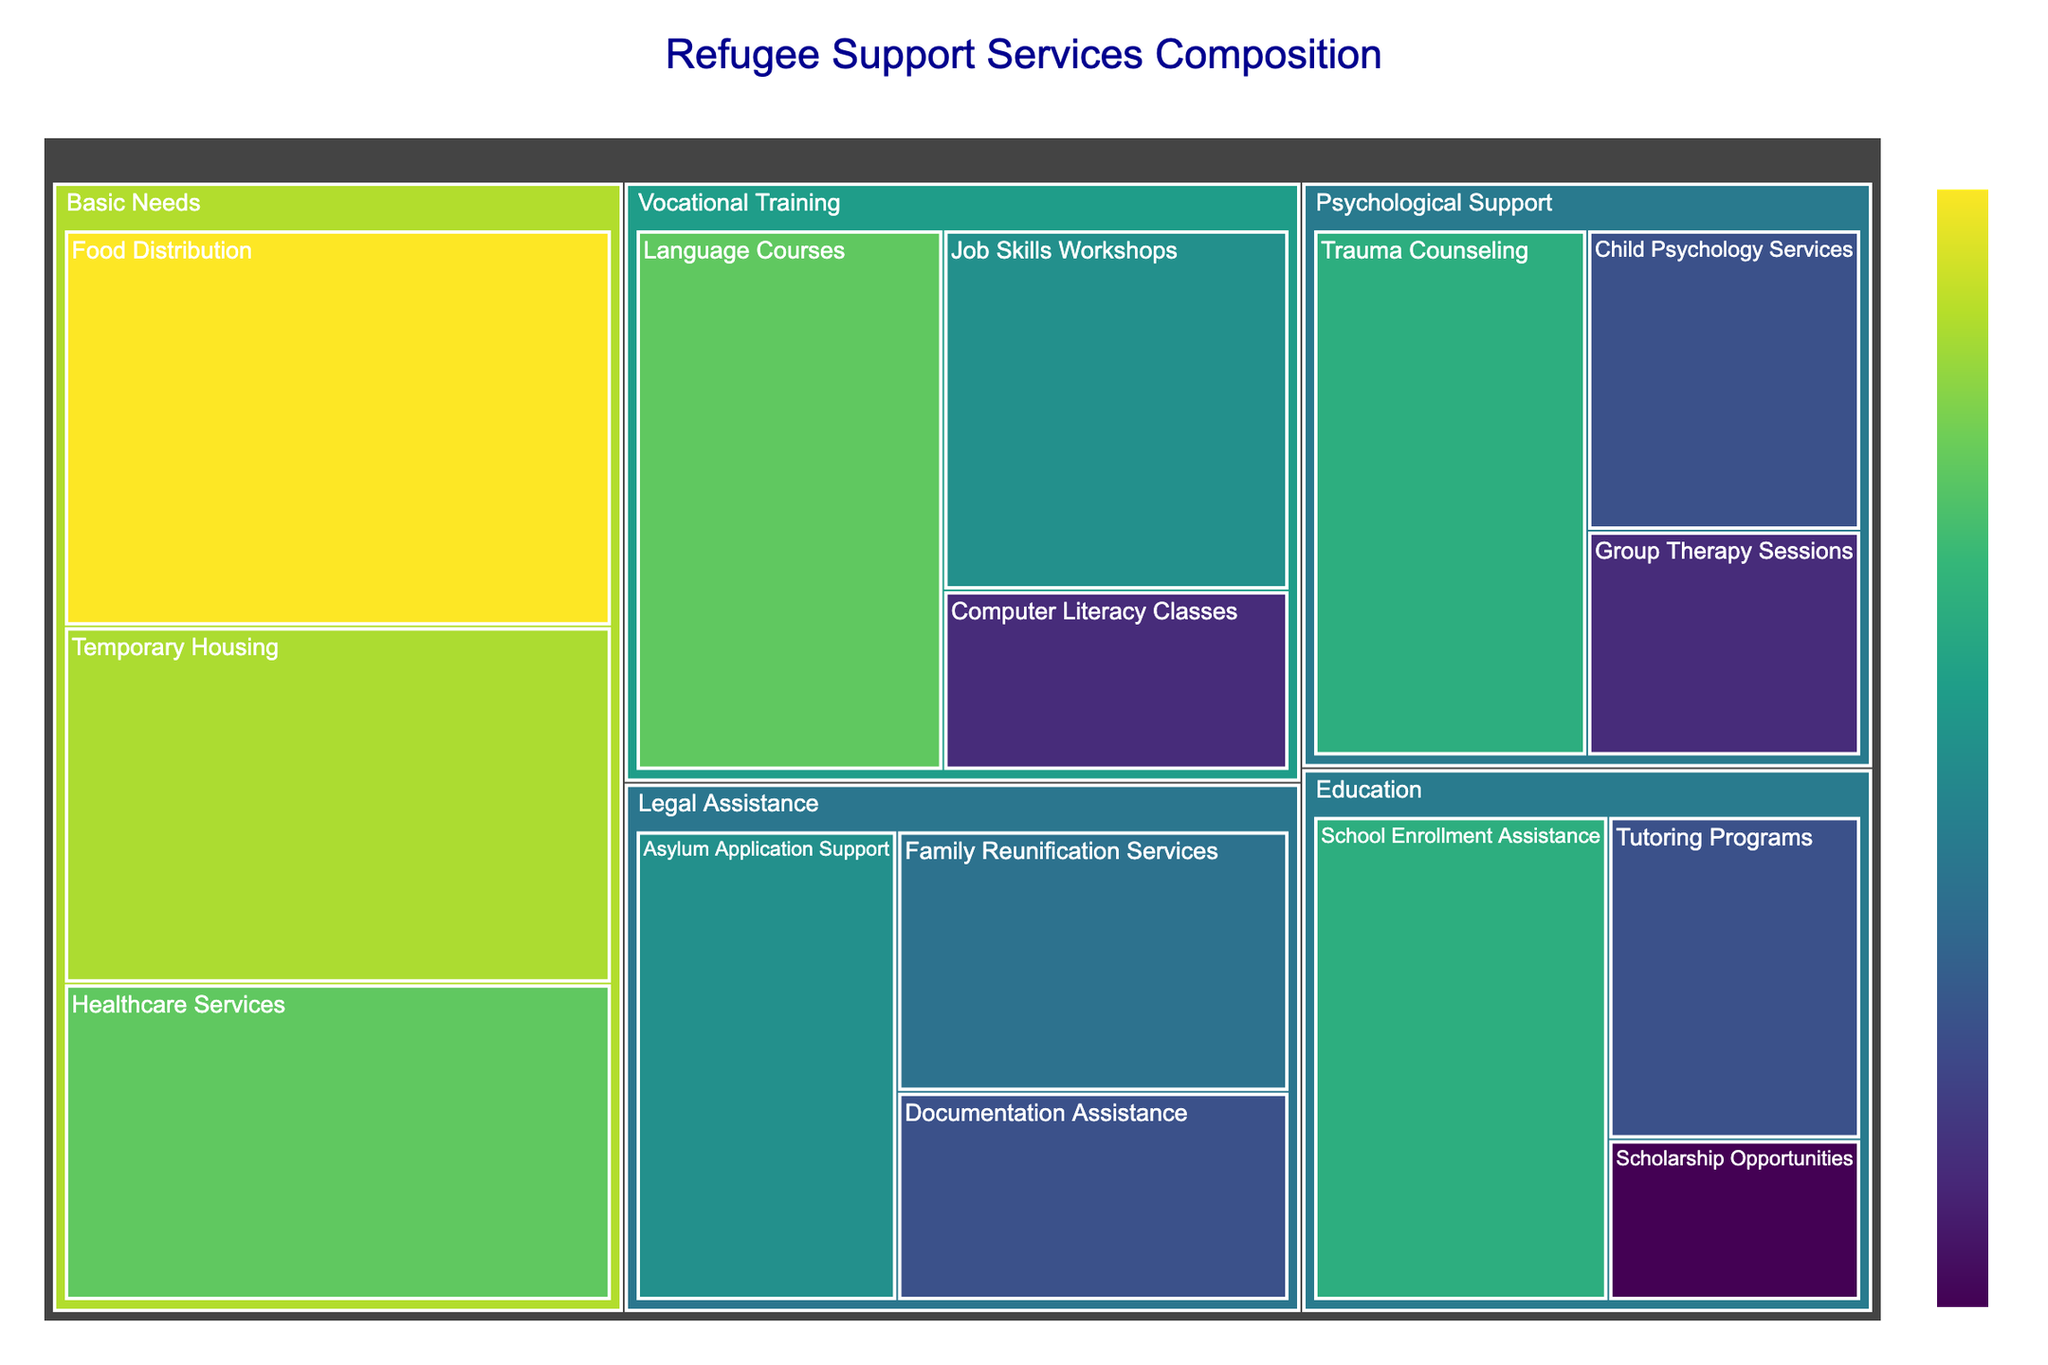What's the title of the treemap? The title of the treemap is usually displayed prominently at the top or near the top of the figure. In this case, it would be shown as specified by the code that generates it.
Answer: Refugee Support Services Composition What category has the largest total value? You need to sum the values of each subcategory within each category and compare these sums. Basic Needs has values 50 (Food Distribution), 45 (Temporary Housing), and 40 (Healthcare Services), summing up to 135, which is larger than any other category.
Answer: Basic Needs Which subcategory provides the highest value of assistance? Look at each subcategory within the treemap and identify the one with the highest value. The subcategory with the highest value is Food Distribution with a value of 50.
Answer: Food Distribution Compare the total values of "Legal Assistance" and "Vocational Training." Which one is higher? Sum the values of the subcategories under each category. Legal Assistance has values of 30, 25, and 20, which sum to 75. Vocational Training has values of 40, 30, and 15, which also sum to 85. Compare the two totals: 75 (Legal Assistance) and 85 (Vocational Training).
Answer: Vocational Training is higher By how much does the value of "Language Courses" exceed "Computer Literacy Classes"? Identify the values of both subcategories: Language Courses has a value of 40, and Computer Literacy Classes has a value of 15. Subtract the latter from the former: 40 - 15 = 25.
Answer: 25 What is the smallest subcategory value within the "Education" category? Look at the subcategory values within Education: School Enrollment Assistance (35), Tutoring Programs (20), and Scholarship Opportunities (10). The smallest value is 10 for Scholarship Opportunities.
Answer: 10 What is the combined value of all "Psychological Support" subcategories? Sum the values of the subcategories: Trauma Counseling (35), Group Therapy Sessions (15), and Child Psychology Services (20). The total is 35 + 15 + 20 = 70.
Answer: 70 Compare the values of “Temporary Housing” and “Healthcare Services.” Which is higher, and by how much? Look at the values: Temporary Housing has a value of 45, and Healthcare Services has a value of 40. Subtract Healthcare Services from Temporary Housing: 45 - 40 = 5.
Answer: Temporary Housing is higher by 5 Which subcategory within the "Legal Assistance" provides the least assistance? Identify the values within Legal Assistance: Asylum Application Support (30), Family Reunification Services (25), and Documentation Assistance (20). The least value is 20 for Documentation Assistance.
Answer: Documentation Assistance 